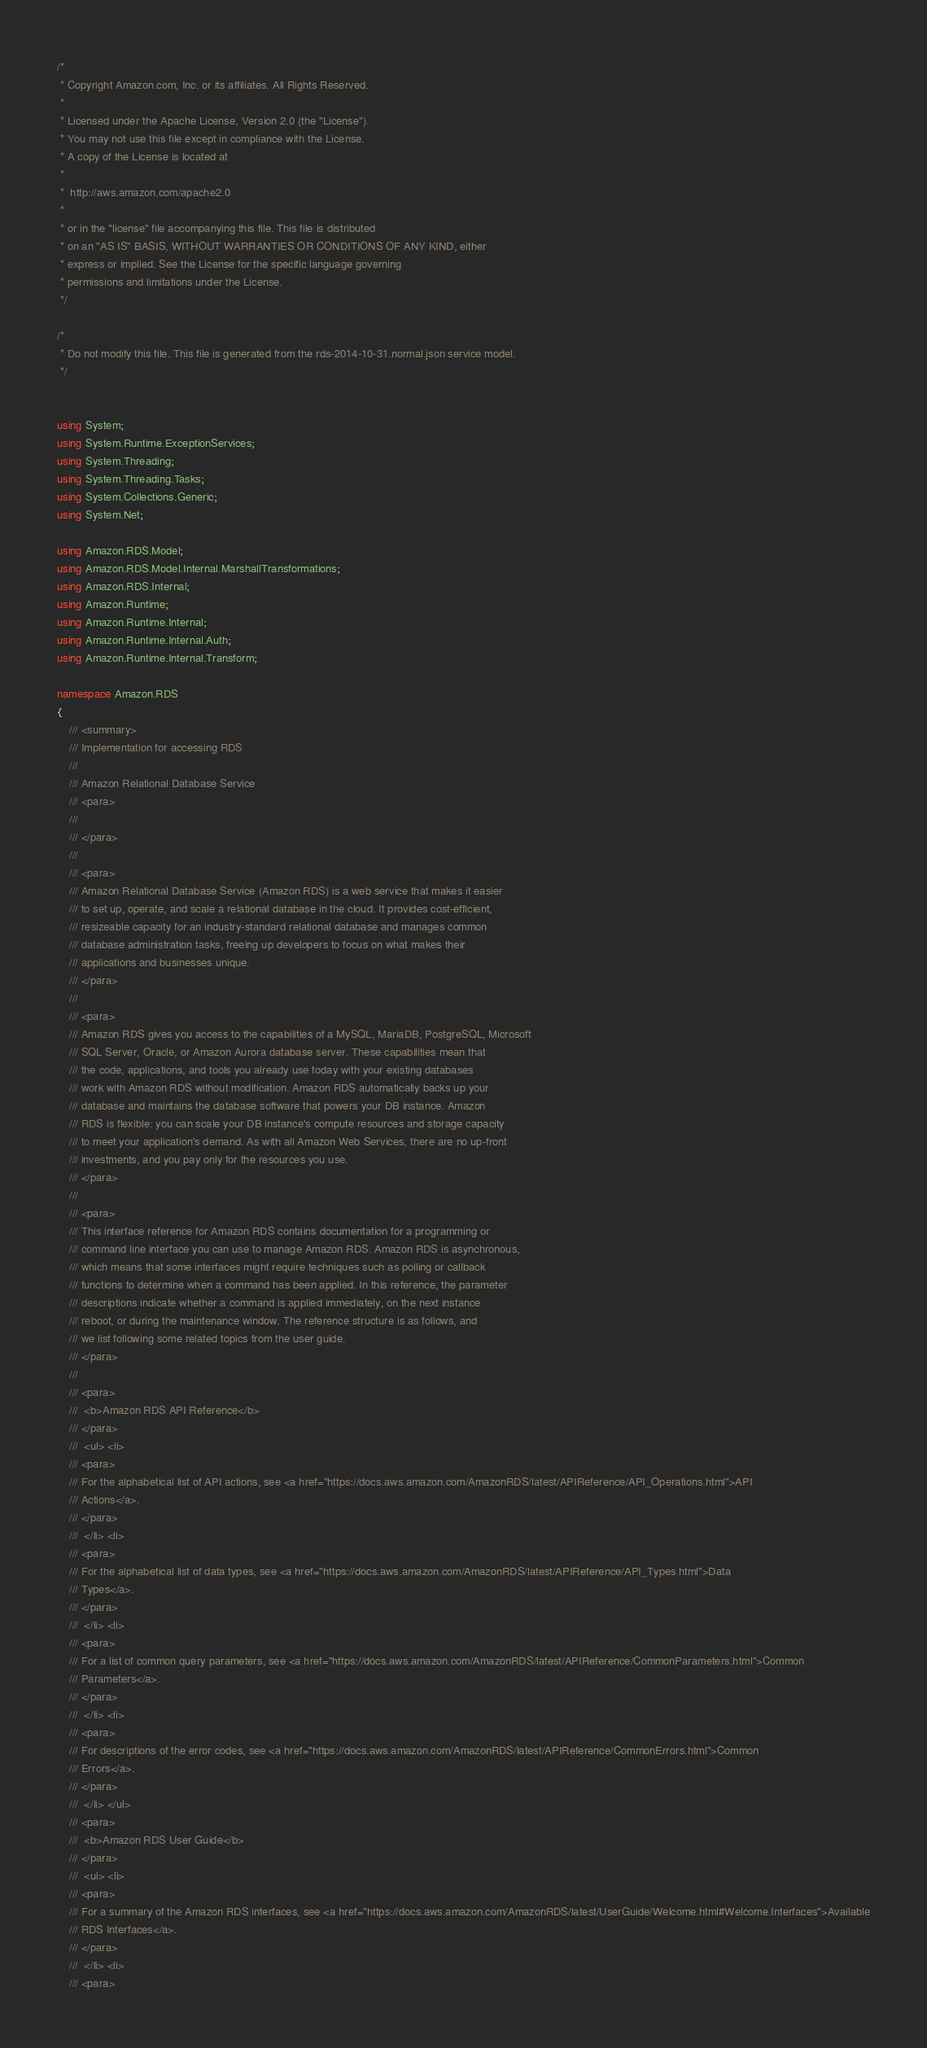Convert code to text. <code><loc_0><loc_0><loc_500><loc_500><_C#_>/*
 * Copyright Amazon.com, Inc. or its affiliates. All Rights Reserved.
 * 
 * Licensed under the Apache License, Version 2.0 (the "License").
 * You may not use this file except in compliance with the License.
 * A copy of the License is located at
 * 
 *  http://aws.amazon.com/apache2.0
 * 
 * or in the "license" file accompanying this file. This file is distributed
 * on an "AS IS" BASIS, WITHOUT WARRANTIES OR CONDITIONS OF ANY KIND, either
 * express or implied. See the License for the specific language governing
 * permissions and limitations under the License.
 */

/*
 * Do not modify this file. This file is generated from the rds-2014-10-31.normal.json service model.
 */


using System;
using System.Runtime.ExceptionServices;
using System.Threading;
using System.Threading.Tasks;
using System.Collections.Generic;
using System.Net;

using Amazon.RDS.Model;
using Amazon.RDS.Model.Internal.MarshallTransformations;
using Amazon.RDS.Internal;
using Amazon.Runtime;
using Amazon.Runtime.Internal;
using Amazon.Runtime.Internal.Auth;
using Amazon.Runtime.Internal.Transform;

namespace Amazon.RDS
{
    /// <summary>
    /// Implementation for accessing RDS
    ///
    /// Amazon Relational Database Service 
    /// <para>
    ///  
    /// </para>
    ///  
    /// <para>
    /// Amazon Relational Database Service (Amazon RDS) is a web service that makes it easier
    /// to set up, operate, and scale a relational database in the cloud. It provides cost-efficient,
    /// resizeable capacity for an industry-standard relational database and manages common
    /// database administration tasks, freeing up developers to focus on what makes their
    /// applications and businesses unique.
    /// </para>
    ///  
    /// <para>
    /// Amazon RDS gives you access to the capabilities of a MySQL, MariaDB, PostgreSQL, Microsoft
    /// SQL Server, Oracle, or Amazon Aurora database server. These capabilities mean that
    /// the code, applications, and tools you already use today with your existing databases
    /// work with Amazon RDS without modification. Amazon RDS automatically backs up your
    /// database and maintains the database software that powers your DB instance. Amazon
    /// RDS is flexible: you can scale your DB instance's compute resources and storage capacity
    /// to meet your application's demand. As with all Amazon Web Services, there are no up-front
    /// investments, and you pay only for the resources you use.
    /// </para>
    ///  
    /// <para>
    /// This interface reference for Amazon RDS contains documentation for a programming or
    /// command line interface you can use to manage Amazon RDS. Amazon RDS is asynchronous,
    /// which means that some interfaces might require techniques such as polling or callback
    /// functions to determine when a command has been applied. In this reference, the parameter
    /// descriptions indicate whether a command is applied immediately, on the next instance
    /// reboot, or during the maintenance window. The reference structure is as follows, and
    /// we list following some related topics from the user guide.
    /// </para>
    ///  
    /// <para>
    ///  <b>Amazon RDS API Reference</b> 
    /// </para>
    ///  <ul> <li> 
    /// <para>
    /// For the alphabetical list of API actions, see <a href="https://docs.aws.amazon.com/AmazonRDS/latest/APIReference/API_Operations.html">API
    /// Actions</a>.
    /// </para>
    ///  </li> <li> 
    /// <para>
    /// For the alphabetical list of data types, see <a href="https://docs.aws.amazon.com/AmazonRDS/latest/APIReference/API_Types.html">Data
    /// Types</a>.
    /// </para>
    ///  </li> <li> 
    /// <para>
    /// For a list of common query parameters, see <a href="https://docs.aws.amazon.com/AmazonRDS/latest/APIReference/CommonParameters.html">Common
    /// Parameters</a>.
    /// </para>
    ///  </li> <li> 
    /// <para>
    /// For descriptions of the error codes, see <a href="https://docs.aws.amazon.com/AmazonRDS/latest/APIReference/CommonErrors.html">Common
    /// Errors</a>.
    /// </para>
    ///  </li> </ul> 
    /// <para>
    ///  <b>Amazon RDS User Guide</b> 
    /// </para>
    ///  <ul> <li> 
    /// <para>
    /// For a summary of the Amazon RDS interfaces, see <a href="https://docs.aws.amazon.com/AmazonRDS/latest/UserGuide/Welcome.html#Welcome.Interfaces">Available
    /// RDS Interfaces</a>.
    /// </para>
    ///  </li> <li> 
    /// <para></code> 